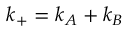Convert formula to latex. <formula><loc_0><loc_0><loc_500><loc_500>k _ { + } = k _ { A } + k _ { B }</formula> 